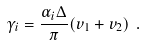Convert formula to latex. <formula><loc_0><loc_0><loc_500><loc_500>\gamma _ { i } = \frac { \alpha _ { i } \Delta } { \pi } ( v _ { 1 } + v _ { 2 } ) \ .</formula> 